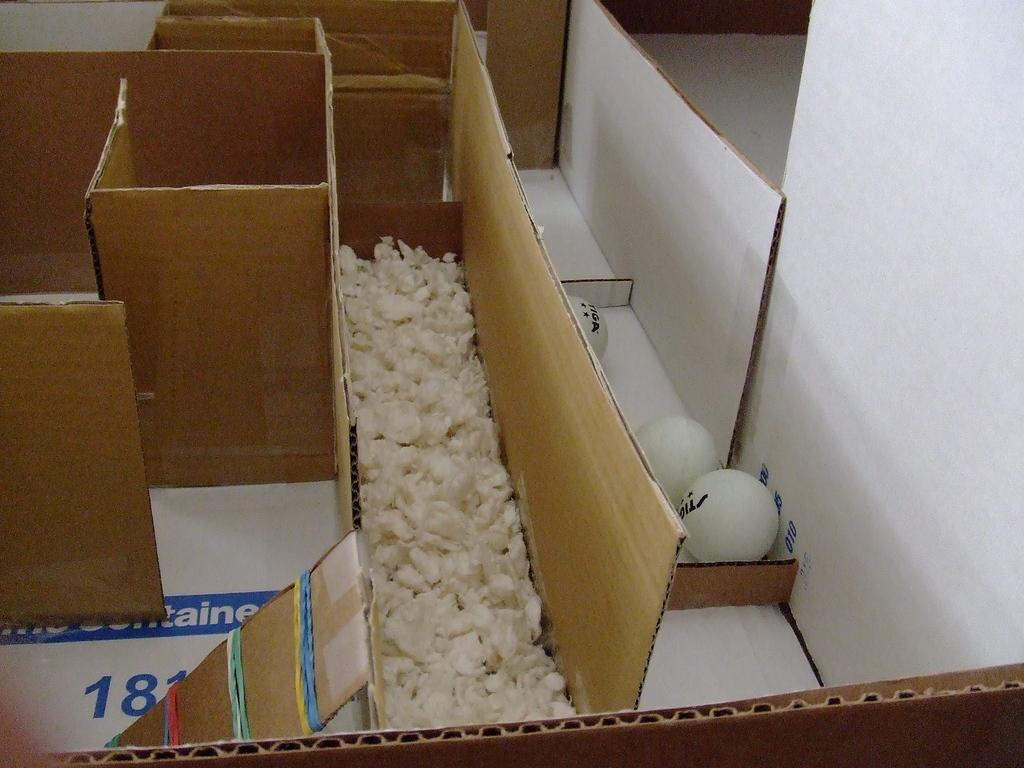<image>
Present a compact description of the photo's key features. a pen for a rodent with the number 181 visible 